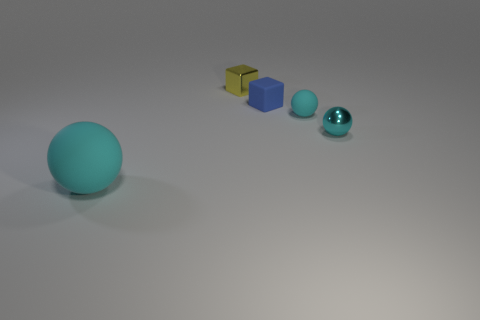Are there any other things that have the same shape as the big rubber thing?
Your answer should be very brief. Yes. Is the small blue object the same shape as the yellow metallic thing?
Your response must be concise. Yes. Are there any other things that are the same material as the yellow thing?
Ensure brevity in your answer.  Yes. What is the size of the rubber cube?
Ensure brevity in your answer.  Small. What color is the rubber thing that is in front of the matte block and on the right side of the large cyan rubber object?
Your answer should be very brief. Cyan. Is the number of blue rubber blocks greater than the number of green metal objects?
Your answer should be compact. Yes. How many things are either big blue rubber cylinders or small things in front of the small yellow shiny cube?
Offer a very short reply. 3. Do the blue matte object and the yellow metallic thing have the same size?
Provide a short and direct response. Yes. There is a tiny metal block; are there any cyan objects behind it?
Your response must be concise. No. How big is the rubber object that is both behind the big matte thing and in front of the rubber block?
Offer a terse response. Small. 